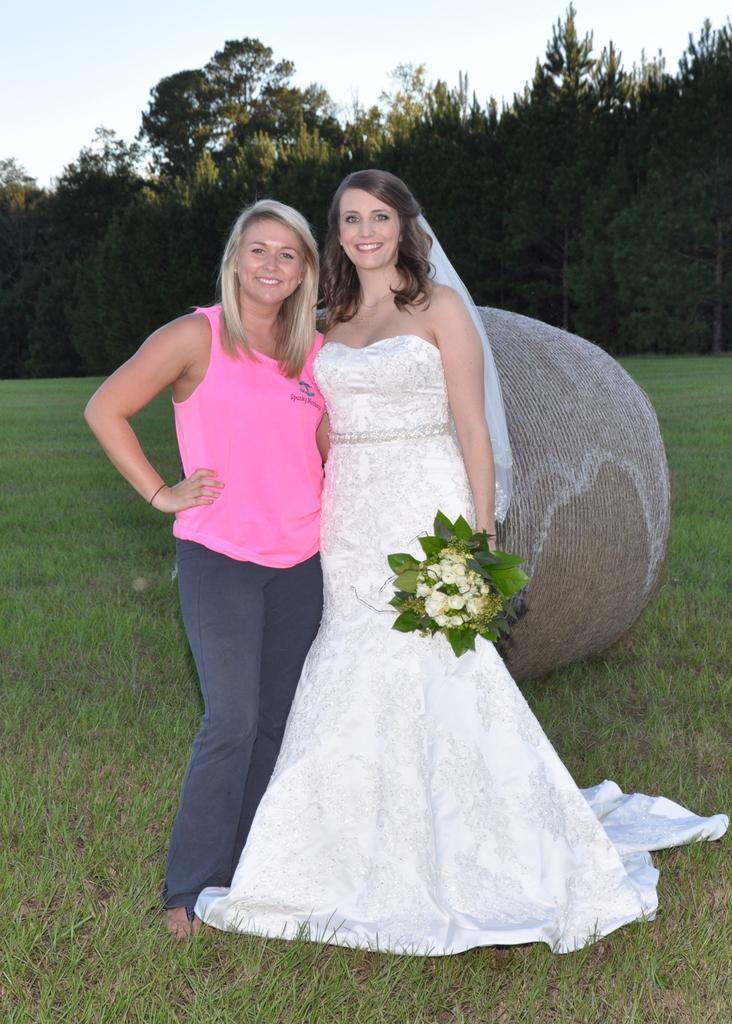How would you summarize this image in a sentence or two? In this image we can see women standing and holding bouquet. In the background we can see grass, trees and sky. 